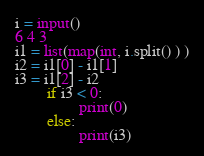<code> <loc_0><loc_0><loc_500><loc_500><_Python_>i = input()
6 4 3
i1 = list(map(int, i.split() ) )
i2 = i1[0] - i1[1]
i3 = i1[2] - i2
		if i3 < 0:
 				print(0)
		else:
 				print(i3)
</code> 